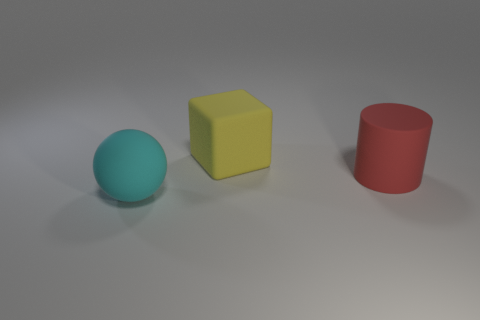Add 3 large brown rubber spheres. How many objects exist? 6 Subtract all balls. How many objects are left? 2 Add 2 cyan balls. How many cyan balls are left? 3 Add 3 small brown metallic cylinders. How many small brown metallic cylinders exist? 3 Subtract 0 green spheres. How many objects are left? 3 Subtract all yellow things. Subtract all big red objects. How many objects are left? 1 